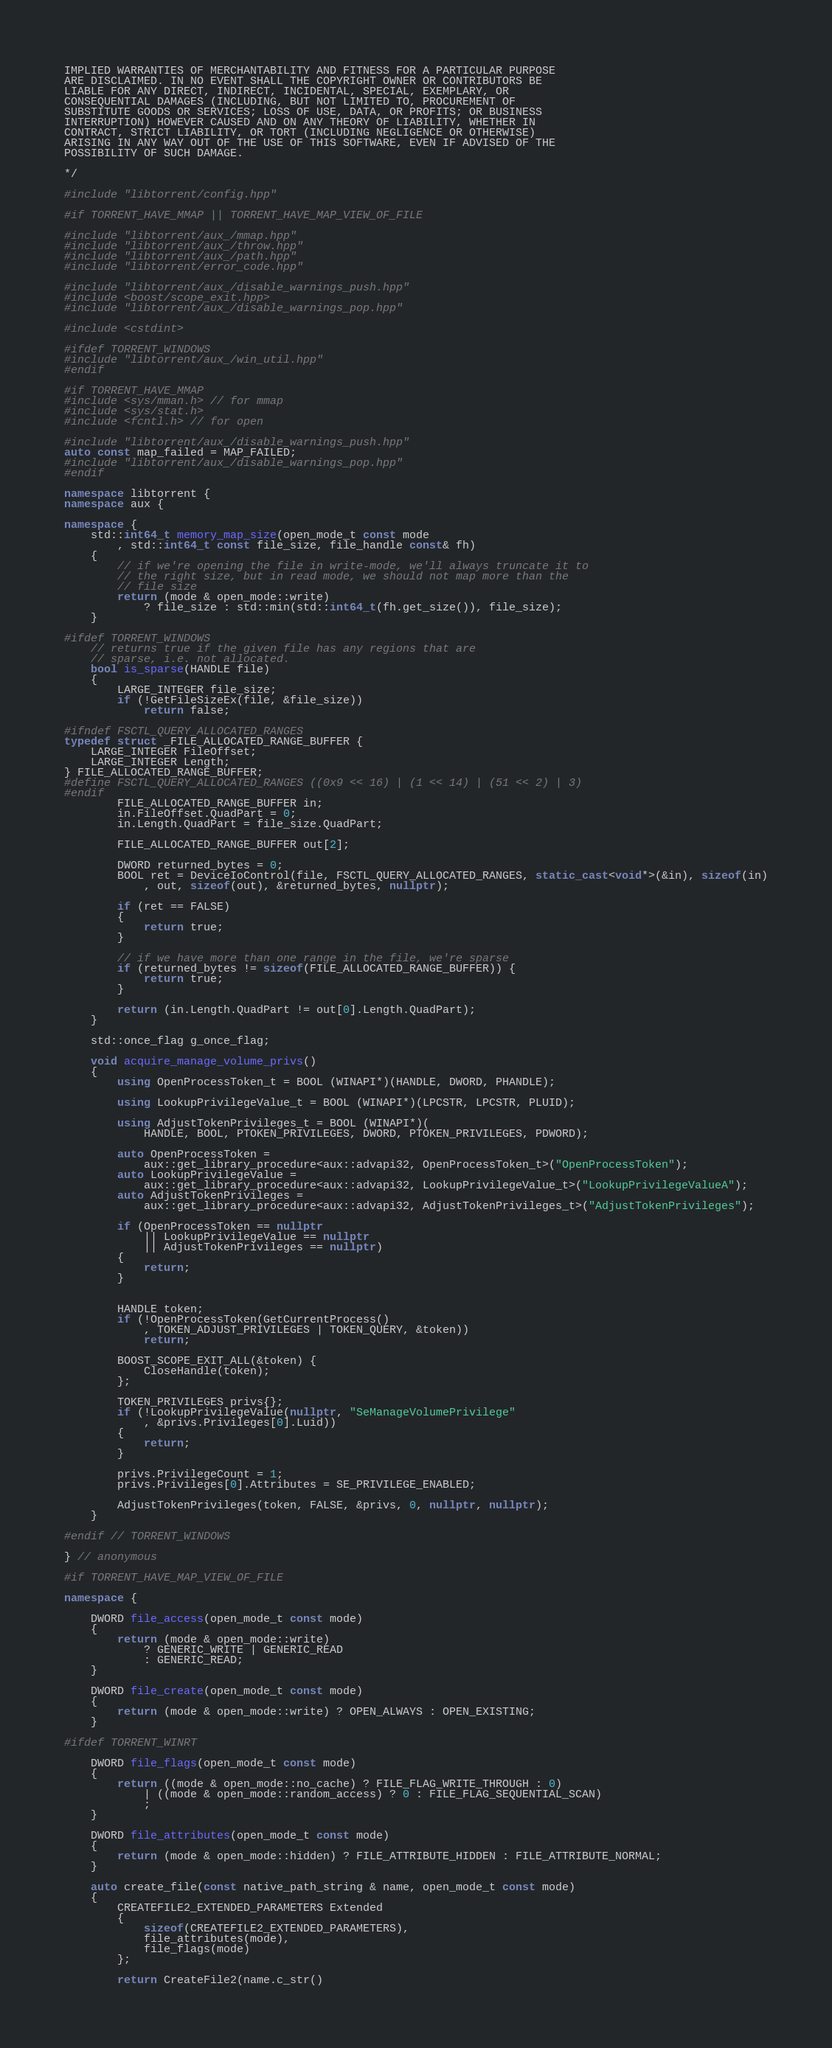<code> <loc_0><loc_0><loc_500><loc_500><_C++_>IMPLIED WARRANTIES OF MERCHANTABILITY AND FITNESS FOR A PARTICULAR PURPOSE
ARE DISCLAIMED. IN NO EVENT SHALL THE COPYRIGHT OWNER OR CONTRIBUTORS BE
LIABLE FOR ANY DIRECT, INDIRECT, INCIDENTAL, SPECIAL, EXEMPLARY, OR
CONSEQUENTIAL DAMAGES (INCLUDING, BUT NOT LIMITED TO, PROCUREMENT OF
SUBSTITUTE GOODS OR SERVICES; LOSS OF USE, DATA, OR PROFITS; OR BUSINESS
INTERRUPTION) HOWEVER CAUSED AND ON ANY THEORY OF LIABILITY, WHETHER IN
CONTRACT, STRICT LIABILITY, OR TORT (INCLUDING NEGLIGENCE OR OTHERWISE)
ARISING IN ANY WAY OUT OF THE USE OF THIS SOFTWARE, EVEN IF ADVISED OF THE
POSSIBILITY OF SUCH DAMAGE.

*/

#include "libtorrent/config.hpp"

#if TORRENT_HAVE_MMAP || TORRENT_HAVE_MAP_VIEW_OF_FILE

#include "libtorrent/aux_/mmap.hpp"
#include "libtorrent/aux_/throw.hpp"
#include "libtorrent/aux_/path.hpp"
#include "libtorrent/error_code.hpp"

#include "libtorrent/aux_/disable_warnings_push.hpp"
#include <boost/scope_exit.hpp>
#include "libtorrent/aux_/disable_warnings_pop.hpp"

#include <cstdint>

#ifdef TORRENT_WINDOWS
#include "libtorrent/aux_/win_util.hpp"
#endif

#if TORRENT_HAVE_MMAP
#include <sys/mman.h> // for mmap
#include <sys/stat.h>
#include <fcntl.h> // for open

#include "libtorrent/aux_/disable_warnings_push.hpp"
auto const map_failed = MAP_FAILED;
#include "libtorrent/aux_/disable_warnings_pop.hpp"
#endif

namespace libtorrent {
namespace aux {

namespace {
	std::int64_t memory_map_size(open_mode_t const mode
		, std::int64_t const file_size, file_handle const& fh)
	{
		// if we're opening the file in write-mode, we'll always truncate it to
		// the right size, but in read mode, we should not map more than the
		// file size
		return (mode & open_mode::write)
			? file_size : std::min(std::int64_t(fh.get_size()), file_size);
	}

#ifdef TORRENT_WINDOWS
	// returns true if the given file has any regions that are
	// sparse, i.e. not allocated.
	bool is_sparse(HANDLE file)
	{
		LARGE_INTEGER file_size;
		if (!GetFileSizeEx(file, &file_size))
			return false;

#ifndef FSCTL_QUERY_ALLOCATED_RANGES
typedef struct _FILE_ALLOCATED_RANGE_BUFFER {
	LARGE_INTEGER FileOffset;
	LARGE_INTEGER Length;
} FILE_ALLOCATED_RANGE_BUFFER;
#define FSCTL_QUERY_ALLOCATED_RANGES ((0x9 << 16) | (1 << 14) | (51 << 2) | 3)
#endif
		FILE_ALLOCATED_RANGE_BUFFER in;
		in.FileOffset.QuadPart = 0;
		in.Length.QuadPart = file_size.QuadPart;

		FILE_ALLOCATED_RANGE_BUFFER out[2];

		DWORD returned_bytes = 0;
		BOOL ret = DeviceIoControl(file, FSCTL_QUERY_ALLOCATED_RANGES, static_cast<void*>(&in), sizeof(in)
			, out, sizeof(out), &returned_bytes, nullptr);

		if (ret == FALSE)
		{
			return true;
		}

		// if we have more than one range in the file, we're sparse
		if (returned_bytes != sizeof(FILE_ALLOCATED_RANGE_BUFFER)) {
			return true;
		}

		return (in.Length.QuadPart != out[0].Length.QuadPart);
	}

	std::once_flag g_once_flag;

	void acquire_manage_volume_privs()
	{
		using OpenProcessToken_t = BOOL (WINAPI*)(HANDLE, DWORD, PHANDLE);

		using LookupPrivilegeValue_t = BOOL (WINAPI*)(LPCSTR, LPCSTR, PLUID);

		using AdjustTokenPrivileges_t = BOOL (WINAPI*)(
			HANDLE, BOOL, PTOKEN_PRIVILEGES, DWORD, PTOKEN_PRIVILEGES, PDWORD);

		auto OpenProcessToken =
			aux::get_library_procedure<aux::advapi32, OpenProcessToken_t>("OpenProcessToken");
		auto LookupPrivilegeValue =
			aux::get_library_procedure<aux::advapi32, LookupPrivilegeValue_t>("LookupPrivilegeValueA");
		auto AdjustTokenPrivileges =
			aux::get_library_procedure<aux::advapi32, AdjustTokenPrivileges_t>("AdjustTokenPrivileges");

		if (OpenProcessToken == nullptr
			|| LookupPrivilegeValue == nullptr
			|| AdjustTokenPrivileges == nullptr)
		{
			return;
		}


		HANDLE token;
		if (!OpenProcessToken(GetCurrentProcess()
			, TOKEN_ADJUST_PRIVILEGES | TOKEN_QUERY, &token))
			return;

		BOOST_SCOPE_EXIT_ALL(&token) {
			CloseHandle(token);
		};

		TOKEN_PRIVILEGES privs{};
		if (!LookupPrivilegeValue(nullptr, "SeManageVolumePrivilege"
			, &privs.Privileges[0].Luid))
		{
			return;
		}

		privs.PrivilegeCount = 1;
		privs.Privileges[0].Attributes = SE_PRIVILEGE_ENABLED;

		AdjustTokenPrivileges(token, FALSE, &privs, 0, nullptr, nullptr);
	}

#endif // TORRENT_WINDOWS

} // anonymous

#if TORRENT_HAVE_MAP_VIEW_OF_FILE

namespace {

	DWORD file_access(open_mode_t const mode)
	{
		return (mode & open_mode::write)
			? GENERIC_WRITE | GENERIC_READ
			: GENERIC_READ;
	}

	DWORD file_create(open_mode_t const mode)
	{
		return (mode & open_mode::write) ? OPEN_ALWAYS : OPEN_EXISTING;
	}

#ifdef TORRENT_WINRT

	DWORD file_flags(open_mode_t const mode)
	{
		return ((mode & open_mode::no_cache) ? FILE_FLAG_WRITE_THROUGH : 0)
			| ((mode & open_mode::random_access) ? 0 : FILE_FLAG_SEQUENTIAL_SCAN)
			;
	}

	DWORD file_attributes(open_mode_t const mode)
	{
		return (mode & open_mode::hidden) ? FILE_ATTRIBUTE_HIDDEN : FILE_ATTRIBUTE_NORMAL;
	}

	auto create_file(const native_path_string & name, open_mode_t const mode)
	{
		CREATEFILE2_EXTENDED_PARAMETERS Extended
		{
			sizeof(CREATEFILE2_EXTENDED_PARAMETERS),
			file_attributes(mode),
			file_flags(mode)
		};

		return CreateFile2(name.c_str()</code> 